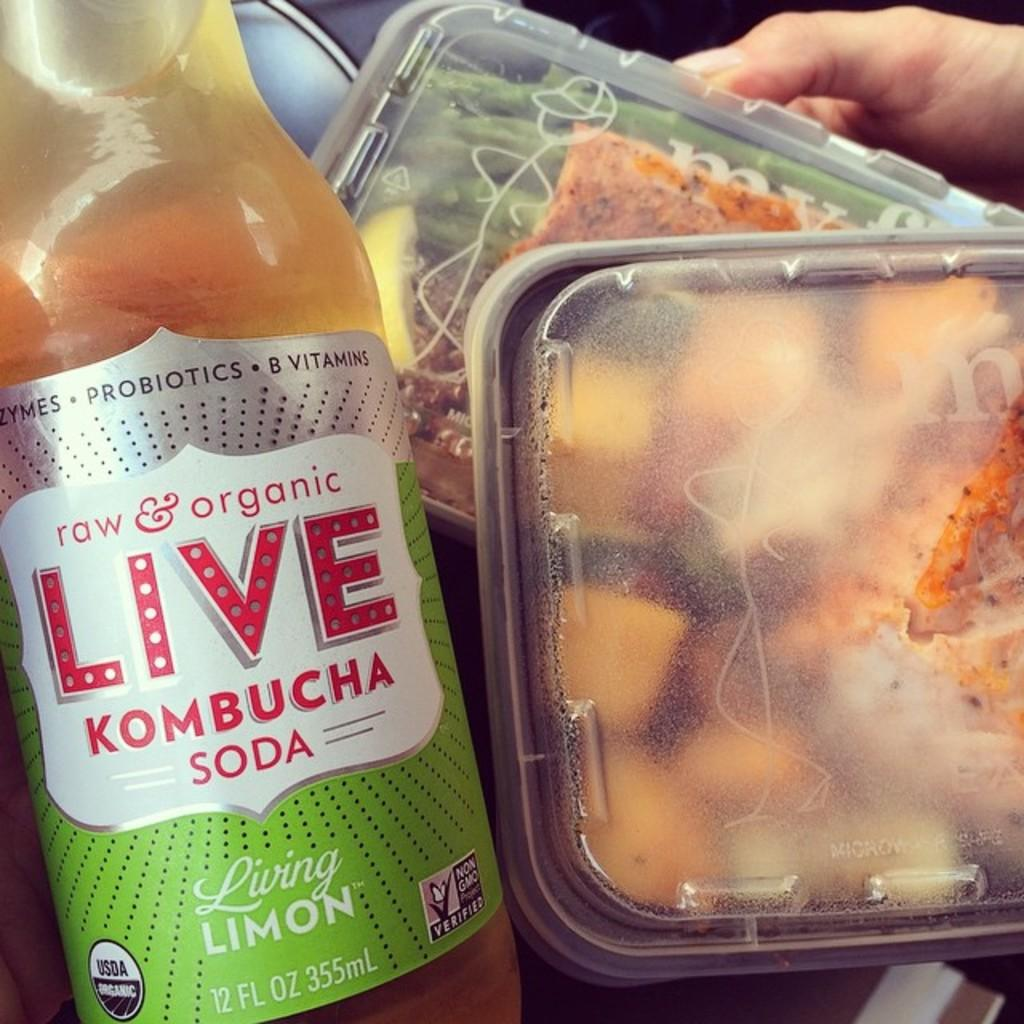What is one of the objects visible in the image? There is a bottle in the image. How many boxes are present in the image? There are two boxes in the image. What is inside the boxes? There is food in the boxes. What type of sail can be seen on the parent in the image? There is no sail or parent present in the image; it only features a bottle and two boxes with food. 